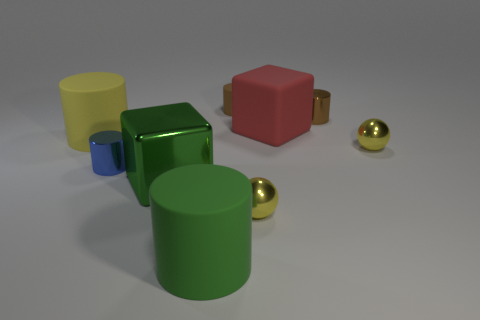How many brown cylinders must be subtracted to get 1 brown cylinders? 1 Subtract 1 cylinders. How many cylinders are left? 4 Subtract all blue cubes. Subtract all red balls. How many cubes are left? 2 Add 1 tiny brown metal things. How many objects exist? 10 Subtract all cylinders. How many objects are left? 4 Add 2 big yellow matte cylinders. How many big yellow matte cylinders are left? 3 Add 1 big green shiny things. How many big green shiny things exist? 2 Subtract 0 brown spheres. How many objects are left? 9 Subtract all large purple shiny balls. Subtract all large yellow objects. How many objects are left? 8 